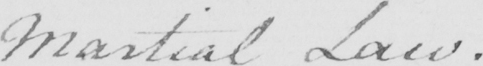Can you read and transcribe this handwriting? Martial Law . 